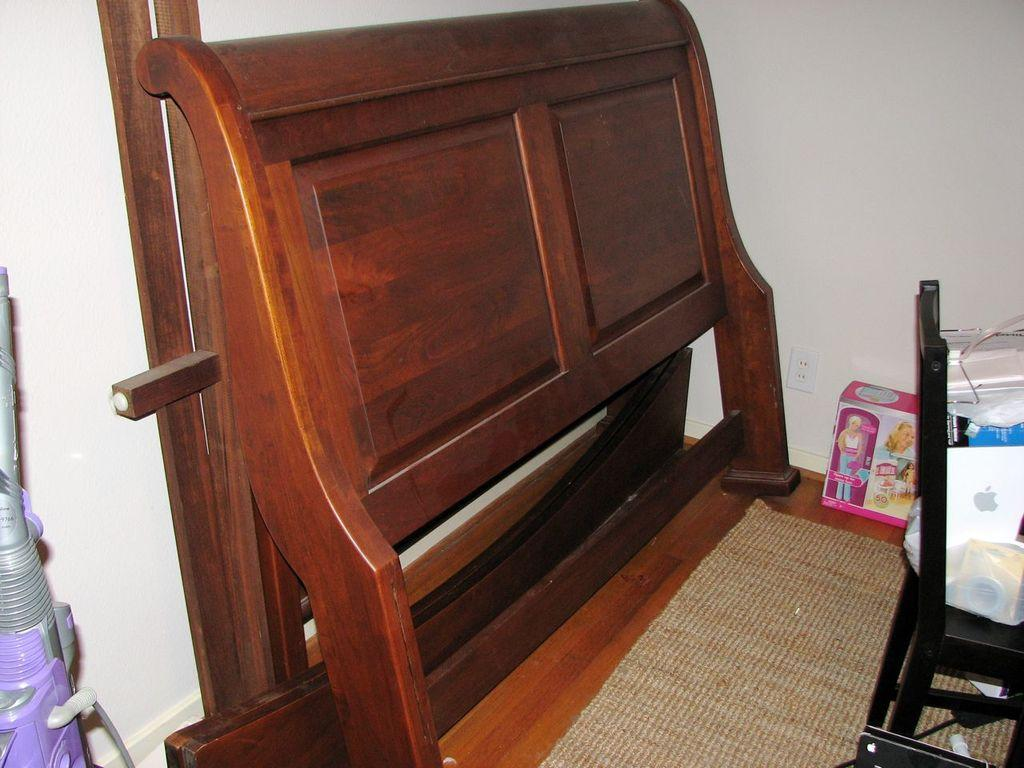What cleaning appliance is visible in the image? There is a vacuum cleaner in the image. What type of furniture is present in the image? There is a chair in the image. What is on top of the chair? There are items on top of the chair. What is on the floor in the image? There is a mat on the floor in the image. What other items can be seen in the image besides the vacuum cleaner and chair? There is a wooden item and a Barbie doll box in the image. Can you see a turkey walking around the vacuum cleaner in the image? There is no turkey present in the image, and therefore no such activity can be observed. Is there a snake wrapped around the wooden item in the image? There is no snake present in the image; only the vacuum cleaner, chair, wooden item, Barbie doll box, and mat are visible. 